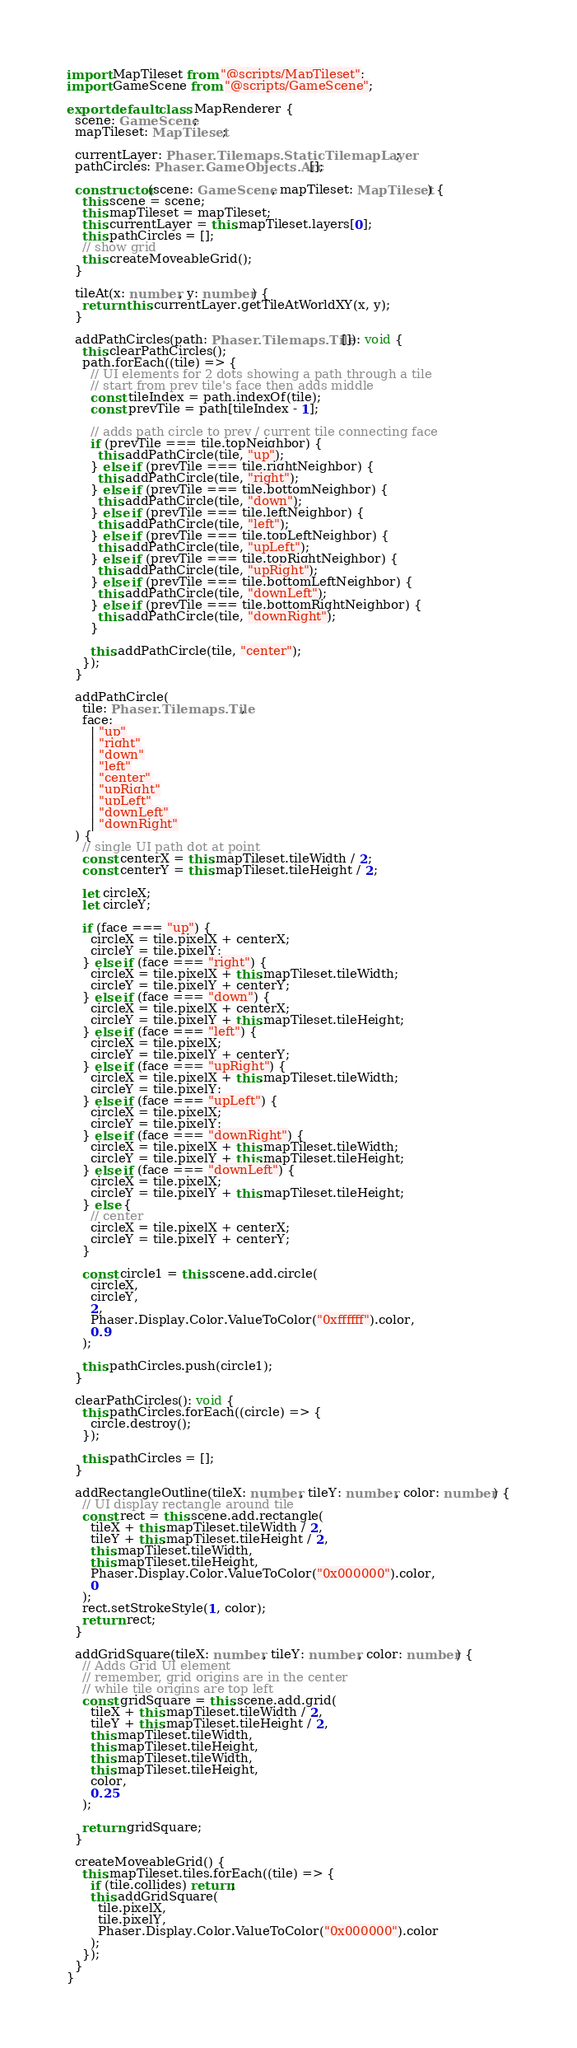Convert code to text. <code><loc_0><loc_0><loc_500><loc_500><_TypeScript_>import MapTileset from "@scripts/MapTileset";
import GameScene from "@scripts/GameScene";

export default class MapRenderer {
  scene: GameScene;
  mapTileset: MapTileset;

  currentLayer: Phaser.Tilemaps.StaticTilemapLayer;
  pathCircles: Phaser.GameObjects.Arc[];

  constructor(scene: GameScene, mapTileset: MapTileset) {
    this.scene = scene;
    this.mapTileset = mapTileset;
    this.currentLayer = this.mapTileset.layers[0];
    this.pathCircles = [];
    // show grid
    this.createMoveableGrid();
  }

  tileAt(x: number, y: number) {
    return this.currentLayer.getTileAtWorldXY(x, y);
  }

  addPathCircles(path: Phaser.Tilemaps.Tile[]): void {
    this.clearPathCircles();
    path.forEach((tile) => {
      // UI elements for 2 dots showing a path through a tile
      // start from prev tile's face then adds middle
      const tileIndex = path.indexOf(tile);
      const prevTile = path[tileIndex - 1];

      // adds path circle to prev / current tile connecting face
      if (prevTile === tile.topNeighbor) {
        this.addPathCircle(tile, "up");
      } else if (prevTile === tile.rightNeighbor) {
        this.addPathCircle(tile, "right");
      } else if (prevTile === tile.bottomNeighbor) {
        this.addPathCircle(tile, "down");
      } else if (prevTile === tile.leftNeighbor) {
        this.addPathCircle(tile, "left");
      } else if (prevTile === tile.topLeftNeighbor) {
        this.addPathCircle(tile, "upLeft");
      } else if (prevTile === tile.topRightNeighbor) {
        this.addPathCircle(tile, "upRight");
      } else if (prevTile === tile.bottomLeftNeighbor) {
        this.addPathCircle(tile, "downLeft");
      } else if (prevTile === tile.bottomRightNeighbor) {
        this.addPathCircle(tile, "downRight");
      }

      this.addPathCircle(tile, "center");
    });
  }

  addPathCircle(
    tile: Phaser.Tilemaps.Tile,
    face:
      | "up"
      | "right"
      | "down"
      | "left"
      | "center"
      | "upRight"
      | "upLeft"
      | "downLeft"
      | "downRight"
  ) {
    // single UI path dot at point
    const centerX = this.mapTileset.tileWidth / 2;
    const centerY = this.mapTileset.tileHeight / 2;

    let circleX;
    let circleY;

    if (face === "up") {
      circleX = tile.pixelX + centerX;
      circleY = tile.pixelY;
    } else if (face === "right") {
      circleX = tile.pixelX + this.mapTileset.tileWidth;
      circleY = tile.pixelY + centerY;
    } else if (face === "down") {
      circleX = tile.pixelX + centerX;
      circleY = tile.pixelY + this.mapTileset.tileHeight;
    } else if (face === "left") {
      circleX = tile.pixelX;
      circleY = tile.pixelY + centerY;
    } else if (face === "upRight") {
      circleX = tile.pixelX + this.mapTileset.tileWidth;
      circleY = tile.pixelY;
    } else if (face === "upLeft") {
      circleX = tile.pixelX;
      circleY = tile.pixelY;
    } else if (face === "downRight") {
      circleX = tile.pixelX + this.mapTileset.tileWidth;
      circleY = tile.pixelY + this.mapTileset.tileHeight;
    } else if (face === "downLeft") {
      circleX = tile.pixelX;
      circleY = tile.pixelY + this.mapTileset.tileHeight;
    } else {
      // center
      circleX = tile.pixelX + centerX;
      circleY = tile.pixelY + centerY;
    }

    const circle1 = this.scene.add.circle(
      circleX,
      circleY,
      2,
      Phaser.Display.Color.ValueToColor("0xffffff").color,
      0.9
    );

    this.pathCircles.push(circle1);
  }

  clearPathCircles(): void {
    this.pathCircles.forEach((circle) => {
      circle.destroy();
    });

    this.pathCircles = [];
  }

  addRectangleOutline(tileX: number, tileY: number, color: number) {
    // UI display rectangle around tile
    const rect = this.scene.add.rectangle(
      tileX + this.mapTileset.tileWidth / 2,
      tileY + this.mapTileset.tileHeight / 2,
      this.mapTileset.tileWidth,
      this.mapTileset.tileHeight,
      Phaser.Display.Color.ValueToColor("0x000000").color,
      0
    );
    rect.setStrokeStyle(1, color);
    return rect;
  }

  addGridSquare(tileX: number, tileY: number, color: number) {
    // Adds Grid UI element
    // remember, grid origins are in the center
    // while tile origins are top left
    const gridSquare = this.scene.add.grid(
      tileX + this.mapTileset.tileWidth / 2,
      tileY + this.mapTileset.tileHeight / 2,
      this.mapTileset.tileWidth,
      this.mapTileset.tileHeight,
      this.mapTileset.tileWidth,
      this.mapTileset.tileHeight,
      color,
      0.25
    );

    return gridSquare;
  }

  createMoveableGrid() {
    this.mapTileset.tiles.forEach((tile) => {
      if (tile.collides) return;
      this.addGridSquare(
        tile.pixelX,
        tile.pixelY,
        Phaser.Display.Color.ValueToColor("0x000000").color
      );
    });
  }
}
</code> 